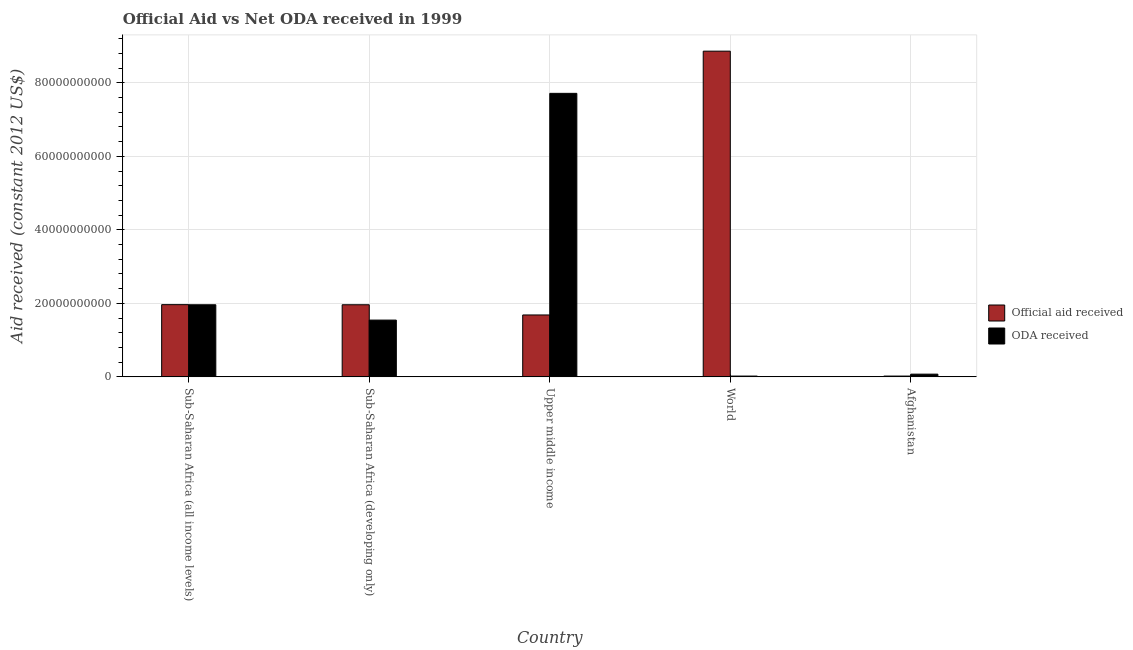How many groups of bars are there?
Offer a terse response. 5. Are the number of bars per tick equal to the number of legend labels?
Provide a short and direct response. Yes. Are the number of bars on each tick of the X-axis equal?
Give a very brief answer. Yes. How many bars are there on the 2nd tick from the left?
Your response must be concise. 2. What is the label of the 4th group of bars from the left?
Make the answer very short. World. What is the oda received in Sub-Saharan Africa (all income levels)?
Offer a very short reply. 1.96e+1. Across all countries, what is the maximum official aid received?
Give a very brief answer. 8.86e+1. Across all countries, what is the minimum oda received?
Give a very brief answer. 2.18e+08. In which country was the official aid received maximum?
Your answer should be compact. World. In which country was the official aid received minimum?
Keep it short and to the point. Afghanistan. What is the total official aid received in the graph?
Provide a succinct answer. 1.45e+11. What is the difference between the official aid received in Sub-Saharan Africa (all income levels) and that in Sub-Saharan Africa (developing only)?
Your answer should be very brief. 3.16e+07. What is the difference between the official aid received in Afghanistan and the oda received in World?
Give a very brief answer. 0. What is the average official aid received per country?
Provide a succinct answer. 2.90e+1. What is the difference between the official aid received and oda received in Upper middle income?
Give a very brief answer. -6.03e+1. What is the ratio of the oda received in Afghanistan to that in World?
Give a very brief answer. 3.4. Is the difference between the oda received in Afghanistan and Sub-Saharan Africa (all income levels) greater than the difference between the official aid received in Afghanistan and Sub-Saharan Africa (all income levels)?
Ensure brevity in your answer.  Yes. What is the difference between the highest and the second highest official aid received?
Provide a succinct answer. 6.90e+1. What is the difference between the highest and the lowest oda received?
Your response must be concise. 7.69e+1. In how many countries, is the oda received greater than the average oda received taken over all countries?
Your answer should be compact. 1. Is the sum of the official aid received in Sub-Saharan Africa (all income levels) and World greater than the maximum oda received across all countries?
Your answer should be compact. Yes. What does the 1st bar from the left in Sub-Saharan Africa (developing only) represents?
Make the answer very short. Official aid received. What does the 1st bar from the right in Sub-Saharan Africa (all income levels) represents?
Keep it short and to the point. ODA received. How many countries are there in the graph?
Your answer should be very brief. 5. What is the difference between two consecutive major ticks on the Y-axis?
Provide a succinct answer. 2.00e+1. Does the graph contain any zero values?
Your answer should be very brief. No. Where does the legend appear in the graph?
Keep it short and to the point. Center right. What is the title of the graph?
Your answer should be compact. Official Aid vs Net ODA received in 1999 . What is the label or title of the Y-axis?
Offer a very short reply. Aid received (constant 2012 US$). What is the Aid received (constant 2012 US$) of Official aid received in Sub-Saharan Africa (all income levels)?
Your response must be concise. 1.96e+1. What is the Aid received (constant 2012 US$) of ODA received in Sub-Saharan Africa (all income levels)?
Offer a terse response. 1.96e+1. What is the Aid received (constant 2012 US$) of Official aid received in Sub-Saharan Africa (developing only)?
Keep it short and to the point. 1.96e+1. What is the Aid received (constant 2012 US$) in ODA received in Sub-Saharan Africa (developing only)?
Offer a very short reply. 1.54e+1. What is the Aid received (constant 2012 US$) in Official aid received in Upper middle income?
Your answer should be very brief. 1.68e+1. What is the Aid received (constant 2012 US$) in ODA received in Upper middle income?
Give a very brief answer. 7.71e+1. What is the Aid received (constant 2012 US$) in Official aid received in World?
Your answer should be very brief. 8.86e+1. What is the Aid received (constant 2012 US$) of ODA received in World?
Your response must be concise. 2.18e+08. What is the Aid received (constant 2012 US$) of Official aid received in Afghanistan?
Provide a succinct answer. 2.18e+08. What is the Aid received (constant 2012 US$) in ODA received in Afghanistan?
Ensure brevity in your answer.  7.41e+08. Across all countries, what is the maximum Aid received (constant 2012 US$) in Official aid received?
Provide a short and direct response. 8.86e+1. Across all countries, what is the maximum Aid received (constant 2012 US$) in ODA received?
Give a very brief answer. 7.71e+1. Across all countries, what is the minimum Aid received (constant 2012 US$) of Official aid received?
Provide a succinct answer. 2.18e+08. Across all countries, what is the minimum Aid received (constant 2012 US$) in ODA received?
Keep it short and to the point. 2.18e+08. What is the total Aid received (constant 2012 US$) in Official aid received in the graph?
Keep it short and to the point. 1.45e+11. What is the total Aid received (constant 2012 US$) of ODA received in the graph?
Make the answer very short. 1.13e+11. What is the difference between the Aid received (constant 2012 US$) of Official aid received in Sub-Saharan Africa (all income levels) and that in Sub-Saharan Africa (developing only)?
Offer a terse response. 3.16e+07. What is the difference between the Aid received (constant 2012 US$) of ODA received in Sub-Saharan Africa (all income levels) and that in Sub-Saharan Africa (developing only)?
Keep it short and to the point. 4.17e+09. What is the difference between the Aid received (constant 2012 US$) of Official aid received in Sub-Saharan Africa (all income levels) and that in Upper middle income?
Offer a terse response. 2.81e+09. What is the difference between the Aid received (constant 2012 US$) in ODA received in Sub-Saharan Africa (all income levels) and that in Upper middle income?
Your response must be concise. -5.75e+1. What is the difference between the Aid received (constant 2012 US$) in Official aid received in Sub-Saharan Africa (all income levels) and that in World?
Give a very brief answer. -6.90e+1. What is the difference between the Aid received (constant 2012 US$) of ODA received in Sub-Saharan Africa (all income levels) and that in World?
Give a very brief answer. 1.94e+1. What is the difference between the Aid received (constant 2012 US$) of Official aid received in Sub-Saharan Africa (all income levels) and that in Afghanistan?
Offer a very short reply. 1.94e+1. What is the difference between the Aid received (constant 2012 US$) of ODA received in Sub-Saharan Africa (all income levels) and that in Afghanistan?
Keep it short and to the point. 1.89e+1. What is the difference between the Aid received (constant 2012 US$) in Official aid received in Sub-Saharan Africa (developing only) and that in Upper middle income?
Ensure brevity in your answer.  2.77e+09. What is the difference between the Aid received (constant 2012 US$) of ODA received in Sub-Saharan Africa (developing only) and that in Upper middle income?
Give a very brief answer. -6.17e+1. What is the difference between the Aid received (constant 2012 US$) in Official aid received in Sub-Saharan Africa (developing only) and that in World?
Your answer should be compact. -6.90e+1. What is the difference between the Aid received (constant 2012 US$) of ODA received in Sub-Saharan Africa (developing only) and that in World?
Offer a very short reply. 1.52e+1. What is the difference between the Aid received (constant 2012 US$) in Official aid received in Sub-Saharan Africa (developing only) and that in Afghanistan?
Your response must be concise. 1.94e+1. What is the difference between the Aid received (constant 2012 US$) in ODA received in Sub-Saharan Africa (developing only) and that in Afghanistan?
Make the answer very short. 1.47e+1. What is the difference between the Aid received (constant 2012 US$) of Official aid received in Upper middle income and that in World?
Give a very brief answer. -7.18e+1. What is the difference between the Aid received (constant 2012 US$) of ODA received in Upper middle income and that in World?
Your answer should be very brief. 7.69e+1. What is the difference between the Aid received (constant 2012 US$) of Official aid received in Upper middle income and that in Afghanistan?
Keep it short and to the point. 1.66e+1. What is the difference between the Aid received (constant 2012 US$) of ODA received in Upper middle income and that in Afghanistan?
Provide a succinct answer. 7.64e+1. What is the difference between the Aid received (constant 2012 US$) of Official aid received in World and that in Afghanistan?
Your answer should be very brief. 8.84e+1. What is the difference between the Aid received (constant 2012 US$) in ODA received in World and that in Afghanistan?
Provide a short and direct response. -5.23e+08. What is the difference between the Aid received (constant 2012 US$) in Official aid received in Sub-Saharan Africa (all income levels) and the Aid received (constant 2012 US$) in ODA received in Sub-Saharan Africa (developing only)?
Give a very brief answer. 4.20e+09. What is the difference between the Aid received (constant 2012 US$) in Official aid received in Sub-Saharan Africa (all income levels) and the Aid received (constant 2012 US$) in ODA received in Upper middle income?
Give a very brief answer. -5.75e+1. What is the difference between the Aid received (constant 2012 US$) in Official aid received in Sub-Saharan Africa (all income levels) and the Aid received (constant 2012 US$) in ODA received in World?
Offer a terse response. 1.94e+1. What is the difference between the Aid received (constant 2012 US$) of Official aid received in Sub-Saharan Africa (all income levels) and the Aid received (constant 2012 US$) of ODA received in Afghanistan?
Your answer should be very brief. 1.89e+1. What is the difference between the Aid received (constant 2012 US$) of Official aid received in Sub-Saharan Africa (developing only) and the Aid received (constant 2012 US$) of ODA received in Upper middle income?
Your response must be concise. -5.75e+1. What is the difference between the Aid received (constant 2012 US$) in Official aid received in Sub-Saharan Africa (developing only) and the Aid received (constant 2012 US$) in ODA received in World?
Ensure brevity in your answer.  1.94e+1. What is the difference between the Aid received (constant 2012 US$) of Official aid received in Sub-Saharan Africa (developing only) and the Aid received (constant 2012 US$) of ODA received in Afghanistan?
Your answer should be very brief. 1.89e+1. What is the difference between the Aid received (constant 2012 US$) of Official aid received in Upper middle income and the Aid received (constant 2012 US$) of ODA received in World?
Give a very brief answer. 1.66e+1. What is the difference between the Aid received (constant 2012 US$) of Official aid received in Upper middle income and the Aid received (constant 2012 US$) of ODA received in Afghanistan?
Your answer should be very brief. 1.61e+1. What is the difference between the Aid received (constant 2012 US$) in Official aid received in World and the Aid received (constant 2012 US$) in ODA received in Afghanistan?
Offer a very short reply. 8.79e+1. What is the average Aid received (constant 2012 US$) in Official aid received per country?
Your answer should be very brief. 2.90e+1. What is the average Aid received (constant 2012 US$) in ODA received per country?
Provide a succinct answer. 2.26e+1. What is the difference between the Aid received (constant 2012 US$) in Official aid received and Aid received (constant 2012 US$) in ODA received in Sub-Saharan Africa (all income levels)?
Make the answer very short. 3.16e+07. What is the difference between the Aid received (constant 2012 US$) in Official aid received and Aid received (constant 2012 US$) in ODA received in Sub-Saharan Africa (developing only)?
Provide a succinct answer. 4.17e+09. What is the difference between the Aid received (constant 2012 US$) in Official aid received and Aid received (constant 2012 US$) in ODA received in Upper middle income?
Provide a succinct answer. -6.03e+1. What is the difference between the Aid received (constant 2012 US$) of Official aid received and Aid received (constant 2012 US$) of ODA received in World?
Offer a very short reply. 8.84e+1. What is the difference between the Aid received (constant 2012 US$) of Official aid received and Aid received (constant 2012 US$) of ODA received in Afghanistan?
Your response must be concise. -5.23e+08. What is the ratio of the Aid received (constant 2012 US$) in ODA received in Sub-Saharan Africa (all income levels) to that in Sub-Saharan Africa (developing only)?
Provide a short and direct response. 1.27. What is the ratio of the Aid received (constant 2012 US$) in Official aid received in Sub-Saharan Africa (all income levels) to that in Upper middle income?
Your answer should be compact. 1.17. What is the ratio of the Aid received (constant 2012 US$) of ODA received in Sub-Saharan Africa (all income levels) to that in Upper middle income?
Offer a very short reply. 0.25. What is the ratio of the Aid received (constant 2012 US$) in Official aid received in Sub-Saharan Africa (all income levels) to that in World?
Give a very brief answer. 0.22. What is the ratio of the Aid received (constant 2012 US$) of ODA received in Sub-Saharan Africa (all income levels) to that in World?
Offer a very short reply. 89.84. What is the ratio of the Aid received (constant 2012 US$) of Official aid received in Sub-Saharan Africa (all income levels) to that in Afghanistan?
Provide a short and direct response. 89.98. What is the ratio of the Aid received (constant 2012 US$) of ODA received in Sub-Saharan Africa (all income levels) to that in Afghanistan?
Your answer should be very brief. 26.46. What is the ratio of the Aid received (constant 2012 US$) in Official aid received in Sub-Saharan Africa (developing only) to that in Upper middle income?
Ensure brevity in your answer.  1.16. What is the ratio of the Aid received (constant 2012 US$) of ODA received in Sub-Saharan Africa (developing only) to that in Upper middle income?
Your answer should be compact. 0.2. What is the ratio of the Aid received (constant 2012 US$) of Official aid received in Sub-Saharan Africa (developing only) to that in World?
Make the answer very short. 0.22. What is the ratio of the Aid received (constant 2012 US$) in ODA received in Sub-Saharan Africa (developing only) to that in World?
Your answer should be compact. 70.74. What is the ratio of the Aid received (constant 2012 US$) in Official aid received in Sub-Saharan Africa (developing only) to that in Afghanistan?
Provide a short and direct response. 89.84. What is the ratio of the Aid received (constant 2012 US$) of ODA received in Sub-Saharan Africa (developing only) to that in Afghanistan?
Provide a short and direct response. 20.84. What is the ratio of the Aid received (constant 2012 US$) of Official aid received in Upper middle income to that in World?
Provide a succinct answer. 0.19. What is the ratio of the Aid received (constant 2012 US$) of ODA received in Upper middle income to that in World?
Offer a terse response. 353.21. What is the ratio of the Aid received (constant 2012 US$) of Official aid received in Upper middle income to that in Afghanistan?
Make the answer very short. 77.13. What is the ratio of the Aid received (constant 2012 US$) of ODA received in Upper middle income to that in Afghanistan?
Your response must be concise. 104.04. What is the ratio of the Aid received (constant 2012 US$) of Official aid received in World to that in Afghanistan?
Offer a very short reply. 405.76. What is the ratio of the Aid received (constant 2012 US$) of ODA received in World to that in Afghanistan?
Your answer should be very brief. 0.29. What is the difference between the highest and the second highest Aid received (constant 2012 US$) of Official aid received?
Your answer should be compact. 6.90e+1. What is the difference between the highest and the second highest Aid received (constant 2012 US$) of ODA received?
Offer a very short reply. 5.75e+1. What is the difference between the highest and the lowest Aid received (constant 2012 US$) of Official aid received?
Your response must be concise. 8.84e+1. What is the difference between the highest and the lowest Aid received (constant 2012 US$) of ODA received?
Provide a succinct answer. 7.69e+1. 